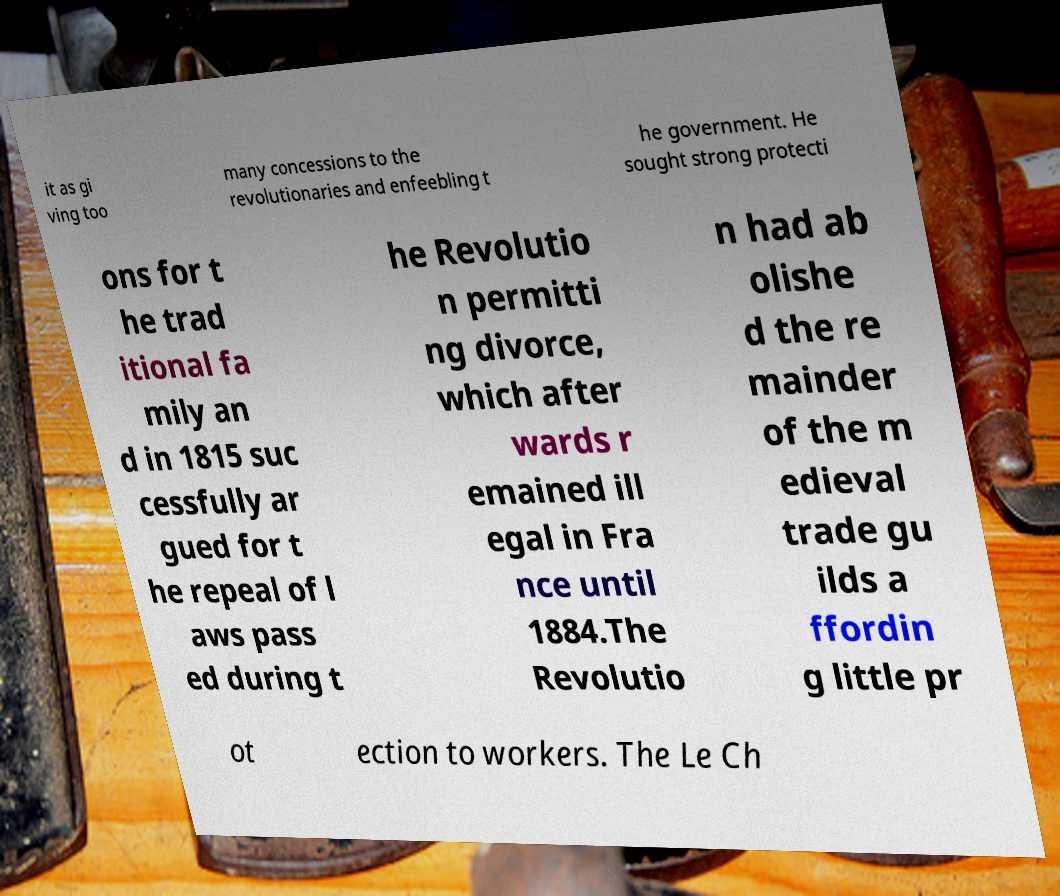I need the written content from this picture converted into text. Can you do that? it as gi ving too many concessions to the revolutionaries and enfeebling t he government. He sought strong protecti ons for t he trad itional fa mily an d in 1815 suc cessfully ar gued for t he repeal of l aws pass ed during t he Revolutio n permitti ng divorce, which after wards r emained ill egal in Fra nce until 1884.The Revolutio n had ab olishe d the re mainder of the m edieval trade gu ilds a ffordin g little pr ot ection to workers. The Le Ch 